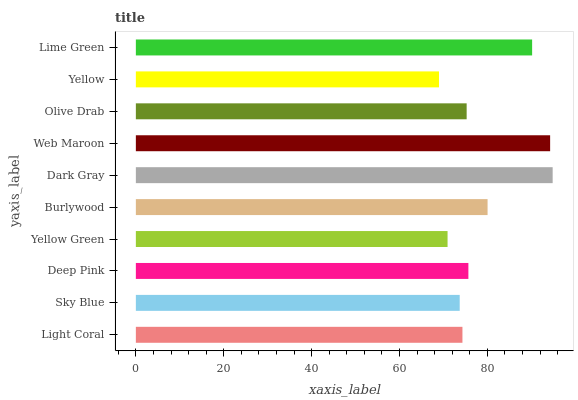Is Yellow the minimum?
Answer yes or no. Yes. Is Dark Gray the maximum?
Answer yes or no. Yes. Is Sky Blue the minimum?
Answer yes or no. No. Is Sky Blue the maximum?
Answer yes or no. No. Is Light Coral greater than Sky Blue?
Answer yes or no. Yes. Is Sky Blue less than Light Coral?
Answer yes or no. Yes. Is Sky Blue greater than Light Coral?
Answer yes or no. No. Is Light Coral less than Sky Blue?
Answer yes or no. No. Is Deep Pink the high median?
Answer yes or no. Yes. Is Olive Drab the low median?
Answer yes or no. Yes. Is Yellow Green the high median?
Answer yes or no. No. Is Deep Pink the low median?
Answer yes or no. No. 